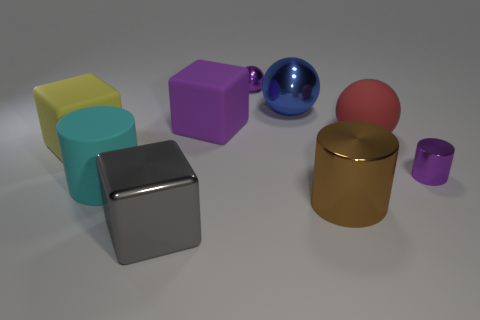Add 1 yellow matte cubes. How many objects exist? 10 Subtract all balls. How many objects are left? 6 Add 9 purple cylinders. How many purple cylinders are left? 10 Add 5 rubber cylinders. How many rubber cylinders exist? 6 Subtract 0 green spheres. How many objects are left? 9 Subtract all cyan rubber things. Subtract all gray metal cubes. How many objects are left? 7 